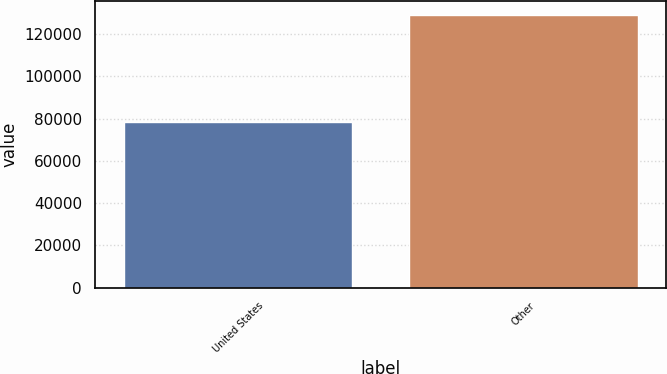Convert chart. <chart><loc_0><loc_0><loc_500><loc_500><bar_chart><fcel>United States<fcel>Other<nl><fcel>78632<fcel>129283<nl></chart> 